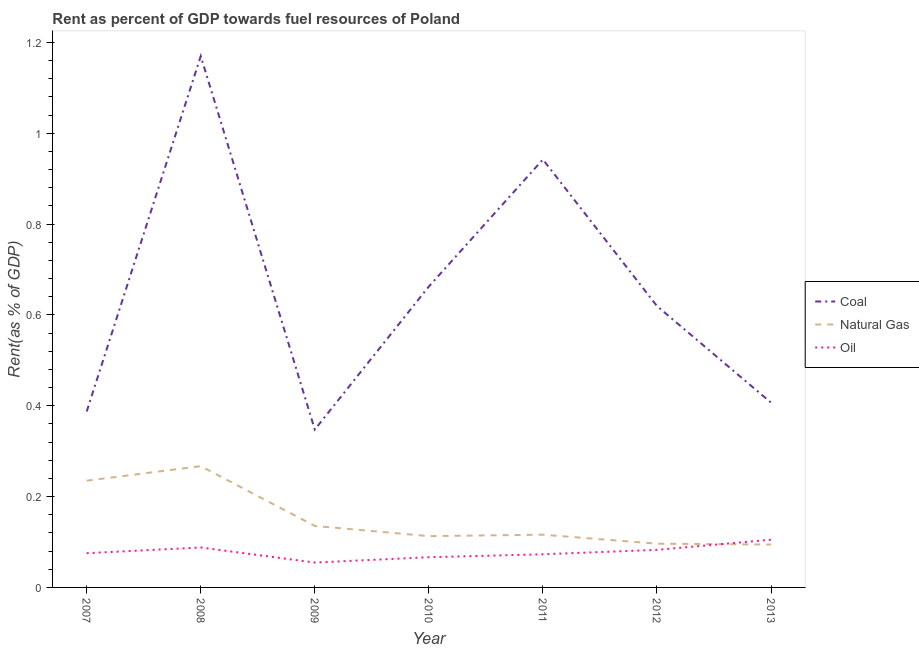What is the rent towards oil in 2011?
Make the answer very short. 0.07. Across all years, what is the maximum rent towards coal?
Your answer should be compact. 1.17. Across all years, what is the minimum rent towards oil?
Provide a short and direct response. 0.05. What is the total rent towards natural gas in the graph?
Keep it short and to the point. 1.06. What is the difference between the rent towards oil in 2010 and that in 2012?
Provide a succinct answer. -0.02. What is the difference between the rent towards oil in 2013 and the rent towards natural gas in 2009?
Make the answer very short. -0.03. What is the average rent towards coal per year?
Your answer should be very brief. 0.65. In the year 2012, what is the difference between the rent towards natural gas and rent towards oil?
Provide a succinct answer. 0.01. What is the ratio of the rent towards natural gas in 2007 to that in 2008?
Offer a terse response. 0.88. Is the difference between the rent towards natural gas in 2010 and 2013 greater than the difference between the rent towards coal in 2010 and 2013?
Offer a very short reply. No. What is the difference between the highest and the second highest rent towards coal?
Your answer should be compact. 0.23. What is the difference between the highest and the lowest rent towards natural gas?
Your answer should be very brief. 0.17. In how many years, is the rent towards oil greater than the average rent towards oil taken over all years?
Keep it short and to the point. 3. Does the rent towards coal monotonically increase over the years?
Provide a succinct answer. No. How many lines are there?
Ensure brevity in your answer.  3. How many years are there in the graph?
Keep it short and to the point. 7. Does the graph contain grids?
Offer a very short reply. No. Where does the legend appear in the graph?
Give a very brief answer. Center right. How are the legend labels stacked?
Offer a terse response. Vertical. What is the title of the graph?
Offer a terse response. Rent as percent of GDP towards fuel resources of Poland. Does "Services" appear as one of the legend labels in the graph?
Provide a succinct answer. No. What is the label or title of the X-axis?
Your answer should be compact. Year. What is the label or title of the Y-axis?
Your response must be concise. Rent(as % of GDP). What is the Rent(as % of GDP) of Coal in 2007?
Ensure brevity in your answer.  0.39. What is the Rent(as % of GDP) in Natural Gas in 2007?
Make the answer very short. 0.24. What is the Rent(as % of GDP) in Oil in 2007?
Offer a terse response. 0.08. What is the Rent(as % of GDP) of Coal in 2008?
Give a very brief answer. 1.17. What is the Rent(as % of GDP) of Natural Gas in 2008?
Provide a succinct answer. 0.27. What is the Rent(as % of GDP) of Oil in 2008?
Make the answer very short. 0.09. What is the Rent(as % of GDP) of Coal in 2009?
Make the answer very short. 0.35. What is the Rent(as % of GDP) of Natural Gas in 2009?
Ensure brevity in your answer.  0.14. What is the Rent(as % of GDP) of Oil in 2009?
Provide a short and direct response. 0.05. What is the Rent(as % of GDP) in Coal in 2010?
Provide a succinct answer. 0.66. What is the Rent(as % of GDP) in Natural Gas in 2010?
Your response must be concise. 0.11. What is the Rent(as % of GDP) in Oil in 2010?
Make the answer very short. 0.07. What is the Rent(as % of GDP) of Coal in 2011?
Your answer should be very brief. 0.94. What is the Rent(as % of GDP) of Natural Gas in 2011?
Give a very brief answer. 0.12. What is the Rent(as % of GDP) of Oil in 2011?
Give a very brief answer. 0.07. What is the Rent(as % of GDP) of Coal in 2012?
Make the answer very short. 0.62. What is the Rent(as % of GDP) in Natural Gas in 2012?
Offer a terse response. 0.1. What is the Rent(as % of GDP) in Oil in 2012?
Your response must be concise. 0.08. What is the Rent(as % of GDP) in Coal in 2013?
Make the answer very short. 0.41. What is the Rent(as % of GDP) of Natural Gas in 2013?
Provide a short and direct response. 0.09. What is the Rent(as % of GDP) of Oil in 2013?
Give a very brief answer. 0.11. Across all years, what is the maximum Rent(as % of GDP) of Coal?
Your response must be concise. 1.17. Across all years, what is the maximum Rent(as % of GDP) in Natural Gas?
Provide a succinct answer. 0.27. Across all years, what is the maximum Rent(as % of GDP) of Oil?
Provide a succinct answer. 0.11. Across all years, what is the minimum Rent(as % of GDP) of Coal?
Ensure brevity in your answer.  0.35. Across all years, what is the minimum Rent(as % of GDP) in Natural Gas?
Make the answer very short. 0.09. Across all years, what is the minimum Rent(as % of GDP) in Oil?
Your answer should be compact. 0.05. What is the total Rent(as % of GDP) of Coal in the graph?
Provide a short and direct response. 4.54. What is the total Rent(as % of GDP) in Natural Gas in the graph?
Ensure brevity in your answer.  1.06. What is the total Rent(as % of GDP) of Oil in the graph?
Make the answer very short. 0.55. What is the difference between the Rent(as % of GDP) of Coal in 2007 and that in 2008?
Offer a terse response. -0.78. What is the difference between the Rent(as % of GDP) of Natural Gas in 2007 and that in 2008?
Keep it short and to the point. -0.03. What is the difference between the Rent(as % of GDP) in Oil in 2007 and that in 2008?
Provide a short and direct response. -0.01. What is the difference between the Rent(as % of GDP) of Coal in 2007 and that in 2009?
Your answer should be compact. 0.04. What is the difference between the Rent(as % of GDP) in Natural Gas in 2007 and that in 2009?
Offer a terse response. 0.1. What is the difference between the Rent(as % of GDP) in Oil in 2007 and that in 2009?
Provide a short and direct response. 0.02. What is the difference between the Rent(as % of GDP) of Coal in 2007 and that in 2010?
Keep it short and to the point. -0.28. What is the difference between the Rent(as % of GDP) in Natural Gas in 2007 and that in 2010?
Offer a very short reply. 0.12. What is the difference between the Rent(as % of GDP) of Oil in 2007 and that in 2010?
Offer a very short reply. 0.01. What is the difference between the Rent(as % of GDP) in Coal in 2007 and that in 2011?
Give a very brief answer. -0.55. What is the difference between the Rent(as % of GDP) of Natural Gas in 2007 and that in 2011?
Your response must be concise. 0.12. What is the difference between the Rent(as % of GDP) in Oil in 2007 and that in 2011?
Make the answer very short. 0. What is the difference between the Rent(as % of GDP) of Coal in 2007 and that in 2012?
Provide a succinct answer. -0.23. What is the difference between the Rent(as % of GDP) in Natural Gas in 2007 and that in 2012?
Provide a short and direct response. 0.14. What is the difference between the Rent(as % of GDP) in Oil in 2007 and that in 2012?
Your answer should be compact. -0.01. What is the difference between the Rent(as % of GDP) in Coal in 2007 and that in 2013?
Offer a terse response. -0.02. What is the difference between the Rent(as % of GDP) in Natural Gas in 2007 and that in 2013?
Provide a short and direct response. 0.14. What is the difference between the Rent(as % of GDP) of Oil in 2007 and that in 2013?
Make the answer very short. -0.03. What is the difference between the Rent(as % of GDP) in Coal in 2008 and that in 2009?
Provide a succinct answer. 0.82. What is the difference between the Rent(as % of GDP) of Natural Gas in 2008 and that in 2009?
Your response must be concise. 0.13. What is the difference between the Rent(as % of GDP) in Oil in 2008 and that in 2009?
Your response must be concise. 0.03. What is the difference between the Rent(as % of GDP) of Coal in 2008 and that in 2010?
Your answer should be compact. 0.51. What is the difference between the Rent(as % of GDP) of Natural Gas in 2008 and that in 2010?
Your response must be concise. 0.15. What is the difference between the Rent(as % of GDP) in Oil in 2008 and that in 2010?
Ensure brevity in your answer.  0.02. What is the difference between the Rent(as % of GDP) of Coal in 2008 and that in 2011?
Ensure brevity in your answer.  0.23. What is the difference between the Rent(as % of GDP) of Natural Gas in 2008 and that in 2011?
Your response must be concise. 0.15. What is the difference between the Rent(as % of GDP) in Oil in 2008 and that in 2011?
Keep it short and to the point. 0.01. What is the difference between the Rent(as % of GDP) in Coal in 2008 and that in 2012?
Give a very brief answer. 0.55. What is the difference between the Rent(as % of GDP) of Natural Gas in 2008 and that in 2012?
Offer a very short reply. 0.17. What is the difference between the Rent(as % of GDP) in Oil in 2008 and that in 2012?
Your answer should be compact. 0.01. What is the difference between the Rent(as % of GDP) of Coal in 2008 and that in 2013?
Ensure brevity in your answer.  0.76. What is the difference between the Rent(as % of GDP) in Natural Gas in 2008 and that in 2013?
Provide a short and direct response. 0.17. What is the difference between the Rent(as % of GDP) in Oil in 2008 and that in 2013?
Your answer should be very brief. -0.02. What is the difference between the Rent(as % of GDP) of Coal in 2009 and that in 2010?
Your answer should be compact. -0.32. What is the difference between the Rent(as % of GDP) in Natural Gas in 2009 and that in 2010?
Provide a succinct answer. 0.02. What is the difference between the Rent(as % of GDP) of Oil in 2009 and that in 2010?
Offer a very short reply. -0.01. What is the difference between the Rent(as % of GDP) of Coal in 2009 and that in 2011?
Your answer should be compact. -0.59. What is the difference between the Rent(as % of GDP) of Natural Gas in 2009 and that in 2011?
Provide a short and direct response. 0.02. What is the difference between the Rent(as % of GDP) of Oil in 2009 and that in 2011?
Your response must be concise. -0.02. What is the difference between the Rent(as % of GDP) in Coal in 2009 and that in 2012?
Make the answer very short. -0.27. What is the difference between the Rent(as % of GDP) of Natural Gas in 2009 and that in 2012?
Keep it short and to the point. 0.04. What is the difference between the Rent(as % of GDP) of Oil in 2009 and that in 2012?
Your answer should be very brief. -0.03. What is the difference between the Rent(as % of GDP) of Coal in 2009 and that in 2013?
Make the answer very short. -0.06. What is the difference between the Rent(as % of GDP) of Natural Gas in 2009 and that in 2013?
Your answer should be very brief. 0.04. What is the difference between the Rent(as % of GDP) in Oil in 2009 and that in 2013?
Provide a short and direct response. -0.05. What is the difference between the Rent(as % of GDP) of Coal in 2010 and that in 2011?
Provide a short and direct response. -0.28. What is the difference between the Rent(as % of GDP) of Natural Gas in 2010 and that in 2011?
Make the answer very short. -0. What is the difference between the Rent(as % of GDP) of Oil in 2010 and that in 2011?
Provide a short and direct response. -0.01. What is the difference between the Rent(as % of GDP) of Coal in 2010 and that in 2012?
Ensure brevity in your answer.  0.04. What is the difference between the Rent(as % of GDP) of Natural Gas in 2010 and that in 2012?
Ensure brevity in your answer.  0.02. What is the difference between the Rent(as % of GDP) of Oil in 2010 and that in 2012?
Your answer should be very brief. -0.02. What is the difference between the Rent(as % of GDP) of Coal in 2010 and that in 2013?
Give a very brief answer. 0.26. What is the difference between the Rent(as % of GDP) in Natural Gas in 2010 and that in 2013?
Offer a terse response. 0.02. What is the difference between the Rent(as % of GDP) of Oil in 2010 and that in 2013?
Your response must be concise. -0.04. What is the difference between the Rent(as % of GDP) of Coal in 2011 and that in 2012?
Your answer should be compact. 0.32. What is the difference between the Rent(as % of GDP) of Natural Gas in 2011 and that in 2012?
Your answer should be compact. 0.02. What is the difference between the Rent(as % of GDP) in Oil in 2011 and that in 2012?
Offer a very short reply. -0.01. What is the difference between the Rent(as % of GDP) in Coal in 2011 and that in 2013?
Give a very brief answer. 0.54. What is the difference between the Rent(as % of GDP) of Natural Gas in 2011 and that in 2013?
Your answer should be very brief. 0.02. What is the difference between the Rent(as % of GDP) in Oil in 2011 and that in 2013?
Give a very brief answer. -0.03. What is the difference between the Rent(as % of GDP) in Coal in 2012 and that in 2013?
Keep it short and to the point. 0.21. What is the difference between the Rent(as % of GDP) of Natural Gas in 2012 and that in 2013?
Offer a terse response. 0. What is the difference between the Rent(as % of GDP) in Oil in 2012 and that in 2013?
Keep it short and to the point. -0.02. What is the difference between the Rent(as % of GDP) in Coal in 2007 and the Rent(as % of GDP) in Natural Gas in 2008?
Give a very brief answer. 0.12. What is the difference between the Rent(as % of GDP) in Coal in 2007 and the Rent(as % of GDP) in Oil in 2008?
Make the answer very short. 0.3. What is the difference between the Rent(as % of GDP) of Natural Gas in 2007 and the Rent(as % of GDP) of Oil in 2008?
Make the answer very short. 0.15. What is the difference between the Rent(as % of GDP) in Coal in 2007 and the Rent(as % of GDP) in Natural Gas in 2009?
Give a very brief answer. 0.25. What is the difference between the Rent(as % of GDP) in Coal in 2007 and the Rent(as % of GDP) in Oil in 2009?
Offer a terse response. 0.33. What is the difference between the Rent(as % of GDP) of Natural Gas in 2007 and the Rent(as % of GDP) of Oil in 2009?
Your answer should be very brief. 0.18. What is the difference between the Rent(as % of GDP) in Coal in 2007 and the Rent(as % of GDP) in Natural Gas in 2010?
Provide a short and direct response. 0.27. What is the difference between the Rent(as % of GDP) of Coal in 2007 and the Rent(as % of GDP) of Oil in 2010?
Your answer should be very brief. 0.32. What is the difference between the Rent(as % of GDP) of Natural Gas in 2007 and the Rent(as % of GDP) of Oil in 2010?
Offer a terse response. 0.17. What is the difference between the Rent(as % of GDP) in Coal in 2007 and the Rent(as % of GDP) in Natural Gas in 2011?
Make the answer very short. 0.27. What is the difference between the Rent(as % of GDP) of Coal in 2007 and the Rent(as % of GDP) of Oil in 2011?
Your response must be concise. 0.31. What is the difference between the Rent(as % of GDP) of Natural Gas in 2007 and the Rent(as % of GDP) of Oil in 2011?
Offer a very short reply. 0.16. What is the difference between the Rent(as % of GDP) in Coal in 2007 and the Rent(as % of GDP) in Natural Gas in 2012?
Ensure brevity in your answer.  0.29. What is the difference between the Rent(as % of GDP) in Coal in 2007 and the Rent(as % of GDP) in Oil in 2012?
Give a very brief answer. 0.3. What is the difference between the Rent(as % of GDP) in Natural Gas in 2007 and the Rent(as % of GDP) in Oil in 2012?
Provide a succinct answer. 0.15. What is the difference between the Rent(as % of GDP) in Coal in 2007 and the Rent(as % of GDP) in Natural Gas in 2013?
Give a very brief answer. 0.29. What is the difference between the Rent(as % of GDP) of Coal in 2007 and the Rent(as % of GDP) of Oil in 2013?
Give a very brief answer. 0.28. What is the difference between the Rent(as % of GDP) of Natural Gas in 2007 and the Rent(as % of GDP) of Oil in 2013?
Give a very brief answer. 0.13. What is the difference between the Rent(as % of GDP) of Coal in 2008 and the Rent(as % of GDP) of Natural Gas in 2009?
Offer a terse response. 1.03. What is the difference between the Rent(as % of GDP) of Coal in 2008 and the Rent(as % of GDP) of Oil in 2009?
Make the answer very short. 1.12. What is the difference between the Rent(as % of GDP) in Natural Gas in 2008 and the Rent(as % of GDP) in Oil in 2009?
Ensure brevity in your answer.  0.21. What is the difference between the Rent(as % of GDP) of Coal in 2008 and the Rent(as % of GDP) of Natural Gas in 2010?
Keep it short and to the point. 1.06. What is the difference between the Rent(as % of GDP) in Coal in 2008 and the Rent(as % of GDP) in Oil in 2010?
Offer a very short reply. 1.1. What is the difference between the Rent(as % of GDP) of Natural Gas in 2008 and the Rent(as % of GDP) of Oil in 2010?
Your response must be concise. 0.2. What is the difference between the Rent(as % of GDP) of Coal in 2008 and the Rent(as % of GDP) of Natural Gas in 2011?
Your response must be concise. 1.05. What is the difference between the Rent(as % of GDP) of Coal in 2008 and the Rent(as % of GDP) of Oil in 2011?
Your answer should be compact. 1.1. What is the difference between the Rent(as % of GDP) in Natural Gas in 2008 and the Rent(as % of GDP) in Oil in 2011?
Your answer should be very brief. 0.19. What is the difference between the Rent(as % of GDP) of Coal in 2008 and the Rent(as % of GDP) of Natural Gas in 2012?
Offer a very short reply. 1.07. What is the difference between the Rent(as % of GDP) of Coal in 2008 and the Rent(as % of GDP) of Oil in 2012?
Give a very brief answer. 1.09. What is the difference between the Rent(as % of GDP) in Natural Gas in 2008 and the Rent(as % of GDP) in Oil in 2012?
Give a very brief answer. 0.18. What is the difference between the Rent(as % of GDP) of Coal in 2008 and the Rent(as % of GDP) of Natural Gas in 2013?
Offer a very short reply. 1.08. What is the difference between the Rent(as % of GDP) in Coal in 2008 and the Rent(as % of GDP) in Oil in 2013?
Ensure brevity in your answer.  1.06. What is the difference between the Rent(as % of GDP) in Natural Gas in 2008 and the Rent(as % of GDP) in Oil in 2013?
Your answer should be compact. 0.16. What is the difference between the Rent(as % of GDP) of Coal in 2009 and the Rent(as % of GDP) of Natural Gas in 2010?
Make the answer very short. 0.23. What is the difference between the Rent(as % of GDP) of Coal in 2009 and the Rent(as % of GDP) of Oil in 2010?
Your response must be concise. 0.28. What is the difference between the Rent(as % of GDP) in Natural Gas in 2009 and the Rent(as % of GDP) in Oil in 2010?
Offer a very short reply. 0.07. What is the difference between the Rent(as % of GDP) in Coal in 2009 and the Rent(as % of GDP) in Natural Gas in 2011?
Give a very brief answer. 0.23. What is the difference between the Rent(as % of GDP) of Coal in 2009 and the Rent(as % of GDP) of Oil in 2011?
Make the answer very short. 0.27. What is the difference between the Rent(as % of GDP) in Natural Gas in 2009 and the Rent(as % of GDP) in Oil in 2011?
Your answer should be compact. 0.06. What is the difference between the Rent(as % of GDP) of Coal in 2009 and the Rent(as % of GDP) of Natural Gas in 2012?
Offer a terse response. 0.25. What is the difference between the Rent(as % of GDP) in Coal in 2009 and the Rent(as % of GDP) in Oil in 2012?
Give a very brief answer. 0.26. What is the difference between the Rent(as % of GDP) of Natural Gas in 2009 and the Rent(as % of GDP) of Oil in 2012?
Keep it short and to the point. 0.05. What is the difference between the Rent(as % of GDP) of Coal in 2009 and the Rent(as % of GDP) of Natural Gas in 2013?
Your answer should be compact. 0.25. What is the difference between the Rent(as % of GDP) of Coal in 2009 and the Rent(as % of GDP) of Oil in 2013?
Your response must be concise. 0.24. What is the difference between the Rent(as % of GDP) in Natural Gas in 2009 and the Rent(as % of GDP) in Oil in 2013?
Give a very brief answer. 0.03. What is the difference between the Rent(as % of GDP) of Coal in 2010 and the Rent(as % of GDP) of Natural Gas in 2011?
Ensure brevity in your answer.  0.55. What is the difference between the Rent(as % of GDP) of Coal in 2010 and the Rent(as % of GDP) of Oil in 2011?
Keep it short and to the point. 0.59. What is the difference between the Rent(as % of GDP) of Coal in 2010 and the Rent(as % of GDP) of Natural Gas in 2012?
Ensure brevity in your answer.  0.57. What is the difference between the Rent(as % of GDP) of Coal in 2010 and the Rent(as % of GDP) of Oil in 2012?
Your answer should be compact. 0.58. What is the difference between the Rent(as % of GDP) of Natural Gas in 2010 and the Rent(as % of GDP) of Oil in 2012?
Make the answer very short. 0.03. What is the difference between the Rent(as % of GDP) of Coal in 2010 and the Rent(as % of GDP) of Natural Gas in 2013?
Your answer should be compact. 0.57. What is the difference between the Rent(as % of GDP) in Coal in 2010 and the Rent(as % of GDP) in Oil in 2013?
Your answer should be very brief. 0.56. What is the difference between the Rent(as % of GDP) of Natural Gas in 2010 and the Rent(as % of GDP) of Oil in 2013?
Ensure brevity in your answer.  0.01. What is the difference between the Rent(as % of GDP) in Coal in 2011 and the Rent(as % of GDP) in Natural Gas in 2012?
Provide a succinct answer. 0.85. What is the difference between the Rent(as % of GDP) of Coal in 2011 and the Rent(as % of GDP) of Oil in 2012?
Offer a terse response. 0.86. What is the difference between the Rent(as % of GDP) in Natural Gas in 2011 and the Rent(as % of GDP) in Oil in 2012?
Your response must be concise. 0.03. What is the difference between the Rent(as % of GDP) of Coal in 2011 and the Rent(as % of GDP) of Natural Gas in 2013?
Offer a very short reply. 0.85. What is the difference between the Rent(as % of GDP) in Coal in 2011 and the Rent(as % of GDP) in Oil in 2013?
Your answer should be compact. 0.84. What is the difference between the Rent(as % of GDP) of Natural Gas in 2011 and the Rent(as % of GDP) of Oil in 2013?
Your response must be concise. 0.01. What is the difference between the Rent(as % of GDP) of Coal in 2012 and the Rent(as % of GDP) of Natural Gas in 2013?
Your response must be concise. 0.53. What is the difference between the Rent(as % of GDP) of Coal in 2012 and the Rent(as % of GDP) of Oil in 2013?
Make the answer very short. 0.51. What is the difference between the Rent(as % of GDP) in Natural Gas in 2012 and the Rent(as % of GDP) in Oil in 2013?
Your answer should be very brief. -0.01. What is the average Rent(as % of GDP) in Coal per year?
Your answer should be compact. 0.65. What is the average Rent(as % of GDP) of Natural Gas per year?
Your answer should be compact. 0.15. What is the average Rent(as % of GDP) in Oil per year?
Your response must be concise. 0.08. In the year 2007, what is the difference between the Rent(as % of GDP) of Coal and Rent(as % of GDP) of Natural Gas?
Ensure brevity in your answer.  0.15. In the year 2007, what is the difference between the Rent(as % of GDP) of Coal and Rent(as % of GDP) of Oil?
Give a very brief answer. 0.31. In the year 2007, what is the difference between the Rent(as % of GDP) in Natural Gas and Rent(as % of GDP) in Oil?
Your response must be concise. 0.16. In the year 2008, what is the difference between the Rent(as % of GDP) of Coal and Rent(as % of GDP) of Natural Gas?
Keep it short and to the point. 0.9. In the year 2008, what is the difference between the Rent(as % of GDP) in Coal and Rent(as % of GDP) in Oil?
Give a very brief answer. 1.08. In the year 2008, what is the difference between the Rent(as % of GDP) of Natural Gas and Rent(as % of GDP) of Oil?
Provide a short and direct response. 0.18. In the year 2009, what is the difference between the Rent(as % of GDP) in Coal and Rent(as % of GDP) in Natural Gas?
Your answer should be very brief. 0.21. In the year 2009, what is the difference between the Rent(as % of GDP) of Coal and Rent(as % of GDP) of Oil?
Offer a very short reply. 0.29. In the year 2009, what is the difference between the Rent(as % of GDP) in Natural Gas and Rent(as % of GDP) in Oil?
Provide a short and direct response. 0.08. In the year 2010, what is the difference between the Rent(as % of GDP) in Coal and Rent(as % of GDP) in Natural Gas?
Your answer should be compact. 0.55. In the year 2010, what is the difference between the Rent(as % of GDP) of Coal and Rent(as % of GDP) of Oil?
Provide a short and direct response. 0.6. In the year 2010, what is the difference between the Rent(as % of GDP) in Natural Gas and Rent(as % of GDP) in Oil?
Your answer should be very brief. 0.05. In the year 2011, what is the difference between the Rent(as % of GDP) in Coal and Rent(as % of GDP) in Natural Gas?
Provide a succinct answer. 0.83. In the year 2011, what is the difference between the Rent(as % of GDP) of Coal and Rent(as % of GDP) of Oil?
Your answer should be very brief. 0.87. In the year 2011, what is the difference between the Rent(as % of GDP) of Natural Gas and Rent(as % of GDP) of Oil?
Ensure brevity in your answer.  0.04. In the year 2012, what is the difference between the Rent(as % of GDP) in Coal and Rent(as % of GDP) in Natural Gas?
Your response must be concise. 0.52. In the year 2012, what is the difference between the Rent(as % of GDP) of Coal and Rent(as % of GDP) of Oil?
Ensure brevity in your answer.  0.54. In the year 2012, what is the difference between the Rent(as % of GDP) of Natural Gas and Rent(as % of GDP) of Oil?
Ensure brevity in your answer.  0.01. In the year 2013, what is the difference between the Rent(as % of GDP) in Coal and Rent(as % of GDP) in Natural Gas?
Your answer should be compact. 0.31. In the year 2013, what is the difference between the Rent(as % of GDP) of Coal and Rent(as % of GDP) of Oil?
Your answer should be compact. 0.3. In the year 2013, what is the difference between the Rent(as % of GDP) of Natural Gas and Rent(as % of GDP) of Oil?
Ensure brevity in your answer.  -0.01. What is the ratio of the Rent(as % of GDP) in Coal in 2007 to that in 2008?
Your answer should be compact. 0.33. What is the ratio of the Rent(as % of GDP) of Natural Gas in 2007 to that in 2008?
Offer a very short reply. 0.88. What is the ratio of the Rent(as % of GDP) of Oil in 2007 to that in 2008?
Give a very brief answer. 0.86. What is the ratio of the Rent(as % of GDP) in Coal in 2007 to that in 2009?
Offer a terse response. 1.11. What is the ratio of the Rent(as % of GDP) in Natural Gas in 2007 to that in 2009?
Provide a short and direct response. 1.74. What is the ratio of the Rent(as % of GDP) of Oil in 2007 to that in 2009?
Ensure brevity in your answer.  1.38. What is the ratio of the Rent(as % of GDP) in Coal in 2007 to that in 2010?
Your answer should be compact. 0.58. What is the ratio of the Rent(as % of GDP) of Natural Gas in 2007 to that in 2010?
Keep it short and to the point. 2.08. What is the ratio of the Rent(as % of GDP) in Oil in 2007 to that in 2010?
Offer a terse response. 1.13. What is the ratio of the Rent(as % of GDP) of Coal in 2007 to that in 2011?
Your response must be concise. 0.41. What is the ratio of the Rent(as % of GDP) in Natural Gas in 2007 to that in 2011?
Make the answer very short. 2.02. What is the ratio of the Rent(as % of GDP) of Oil in 2007 to that in 2011?
Your answer should be compact. 1.03. What is the ratio of the Rent(as % of GDP) in Coal in 2007 to that in 2012?
Your response must be concise. 0.63. What is the ratio of the Rent(as % of GDP) in Natural Gas in 2007 to that in 2012?
Give a very brief answer. 2.44. What is the ratio of the Rent(as % of GDP) of Oil in 2007 to that in 2012?
Provide a succinct answer. 0.91. What is the ratio of the Rent(as % of GDP) in Coal in 2007 to that in 2013?
Your answer should be compact. 0.95. What is the ratio of the Rent(as % of GDP) in Natural Gas in 2007 to that in 2013?
Ensure brevity in your answer.  2.49. What is the ratio of the Rent(as % of GDP) of Oil in 2007 to that in 2013?
Provide a succinct answer. 0.72. What is the ratio of the Rent(as % of GDP) of Coal in 2008 to that in 2009?
Give a very brief answer. 3.36. What is the ratio of the Rent(as % of GDP) in Natural Gas in 2008 to that in 2009?
Your answer should be very brief. 1.97. What is the ratio of the Rent(as % of GDP) of Oil in 2008 to that in 2009?
Your answer should be very brief. 1.61. What is the ratio of the Rent(as % of GDP) of Coal in 2008 to that in 2010?
Provide a short and direct response. 1.77. What is the ratio of the Rent(as % of GDP) in Natural Gas in 2008 to that in 2010?
Offer a terse response. 2.36. What is the ratio of the Rent(as % of GDP) in Oil in 2008 to that in 2010?
Your response must be concise. 1.32. What is the ratio of the Rent(as % of GDP) in Coal in 2008 to that in 2011?
Offer a very short reply. 1.24. What is the ratio of the Rent(as % of GDP) of Natural Gas in 2008 to that in 2011?
Provide a succinct answer. 2.3. What is the ratio of the Rent(as % of GDP) in Oil in 2008 to that in 2011?
Give a very brief answer. 1.21. What is the ratio of the Rent(as % of GDP) of Coal in 2008 to that in 2012?
Keep it short and to the point. 1.89. What is the ratio of the Rent(as % of GDP) in Natural Gas in 2008 to that in 2012?
Ensure brevity in your answer.  2.77. What is the ratio of the Rent(as % of GDP) of Oil in 2008 to that in 2012?
Your response must be concise. 1.06. What is the ratio of the Rent(as % of GDP) in Coal in 2008 to that in 2013?
Ensure brevity in your answer.  2.87. What is the ratio of the Rent(as % of GDP) in Natural Gas in 2008 to that in 2013?
Provide a succinct answer. 2.83. What is the ratio of the Rent(as % of GDP) of Oil in 2008 to that in 2013?
Your answer should be very brief. 0.84. What is the ratio of the Rent(as % of GDP) in Coal in 2009 to that in 2010?
Give a very brief answer. 0.52. What is the ratio of the Rent(as % of GDP) in Natural Gas in 2009 to that in 2010?
Offer a terse response. 1.2. What is the ratio of the Rent(as % of GDP) in Oil in 2009 to that in 2010?
Ensure brevity in your answer.  0.82. What is the ratio of the Rent(as % of GDP) of Coal in 2009 to that in 2011?
Ensure brevity in your answer.  0.37. What is the ratio of the Rent(as % of GDP) of Natural Gas in 2009 to that in 2011?
Your answer should be compact. 1.17. What is the ratio of the Rent(as % of GDP) in Oil in 2009 to that in 2011?
Your answer should be compact. 0.75. What is the ratio of the Rent(as % of GDP) in Coal in 2009 to that in 2012?
Keep it short and to the point. 0.56. What is the ratio of the Rent(as % of GDP) of Natural Gas in 2009 to that in 2012?
Your answer should be very brief. 1.41. What is the ratio of the Rent(as % of GDP) of Oil in 2009 to that in 2012?
Make the answer very short. 0.66. What is the ratio of the Rent(as % of GDP) in Coal in 2009 to that in 2013?
Offer a very short reply. 0.85. What is the ratio of the Rent(as % of GDP) in Natural Gas in 2009 to that in 2013?
Offer a terse response. 1.43. What is the ratio of the Rent(as % of GDP) of Oil in 2009 to that in 2013?
Ensure brevity in your answer.  0.52. What is the ratio of the Rent(as % of GDP) of Coal in 2010 to that in 2011?
Give a very brief answer. 0.7. What is the ratio of the Rent(as % of GDP) of Natural Gas in 2010 to that in 2011?
Provide a short and direct response. 0.97. What is the ratio of the Rent(as % of GDP) in Oil in 2010 to that in 2011?
Provide a succinct answer. 0.91. What is the ratio of the Rent(as % of GDP) of Coal in 2010 to that in 2012?
Offer a terse response. 1.07. What is the ratio of the Rent(as % of GDP) of Natural Gas in 2010 to that in 2012?
Your answer should be compact. 1.17. What is the ratio of the Rent(as % of GDP) in Oil in 2010 to that in 2012?
Provide a short and direct response. 0.8. What is the ratio of the Rent(as % of GDP) in Coal in 2010 to that in 2013?
Your answer should be very brief. 1.63. What is the ratio of the Rent(as % of GDP) of Natural Gas in 2010 to that in 2013?
Keep it short and to the point. 1.2. What is the ratio of the Rent(as % of GDP) of Oil in 2010 to that in 2013?
Offer a terse response. 0.63. What is the ratio of the Rent(as % of GDP) of Coal in 2011 to that in 2012?
Provide a short and direct response. 1.52. What is the ratio of the Rent(as % of GDP) in Natural Gas in 2011 to that in 2012?
Ensure brevity in your answer.  1.21. What is the ratio of the Rent(as % of GDP) in Oil in 2011 to that in 2012?
Offer a terse response. 0.88. What is the ratio of the Rent(as % of GDP) in Coal in 2011 to that in 2013?
Provide a short and direct response. 2.32. What is the ratio of the Rent(as % of GDP) of Natural Gas in 2011 to that in 2013?
Give a very brief answer. 1.23. What is the ratio of the Rent(as % of GDP) in Oil in 2011 to that in 2013?
Your response must be concise. 0.69. What is the ratio of the Rent(as % of GDP) of Coal in 2012 to that in 2013?
Your response must be concise. 1.52. What is the ratio of the Rent(as % of GDP) of Natural Gas in 2012 to that in 2013?
Make the answer very short. 1.02. What is the ratio of the Rent(as % of GDP) of Oil in 2012 to that in 2013?
Make the answer very short. 0.79. What is the difference between the highest and the second highest Rent(as % of GDP) in Coal?
Your answer should be compact. 0.23. What is the difference between the highest and the second highest Rent(as % of GDP) of Natural Gas?
Keep it short and to the point. 0.03. What is the difference between the highest and the second highest Rent(as % of GDP) in Oil?
Offer a very short reply. 0.02. What is the difference between the highest and the lowest Rent(as % of GDP) in Coal?
Provide a short and direct response. 0.82. What is the difference between the highest and the lowest Rent(as % of GDP) of Natural Gas?
Your response must be concise. 0.17. What is the difference between the highest and the lowest Rent(as % of GDP) in Oil?
Offer a terse response. 0.05. 